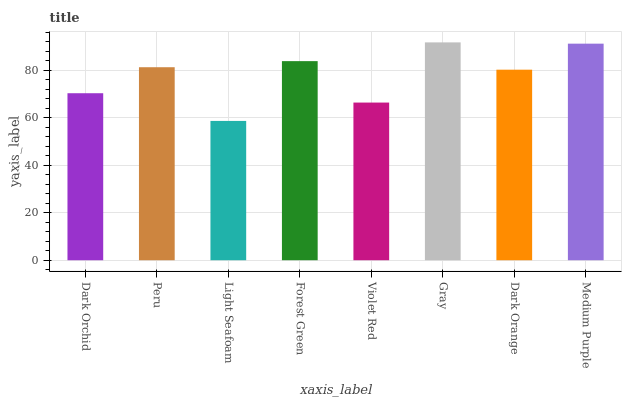Is Light Seafoam the minimum?
Answer yes or no. Yes. Is Gray the maximum?
Answer yes or no. Yes. Is Peru the minimum?
Answer yes or no. No. Is Peru the maximum?
Answer yes or no. No. Is Peru greater than Dark Orchid?
Answer yes or no. Yes. Is Dark Orchid less than Peru?
Answer yes or no. Yes. Is Dark Orchid greater than Peru?
Answer yes or no. No. Is Peru less than Dark Orchid?
Answer yes or no. No. Is Peru the high median?
Answer yes or no. Yes. Is Dark Orange the low median?
Answer yes or no. Yes. Is Violet Red the high median?
Answer yes or no. No. Is Dark Orchid the low median?
Answer yes or no. No. 